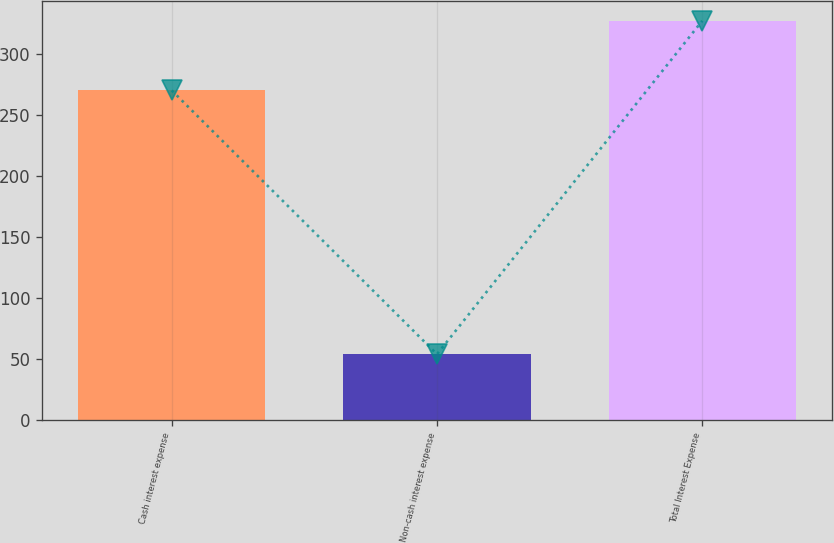Convert chart. <chart><loc_0><loc_0><loc_500><loc_500><bar_chart><fcel>Cash interest expense<fcel>Non-cash interest expense<fcel>Total Interest Expense<nl><fcel>270<fcel>54<fcel>327<nl></chart> 